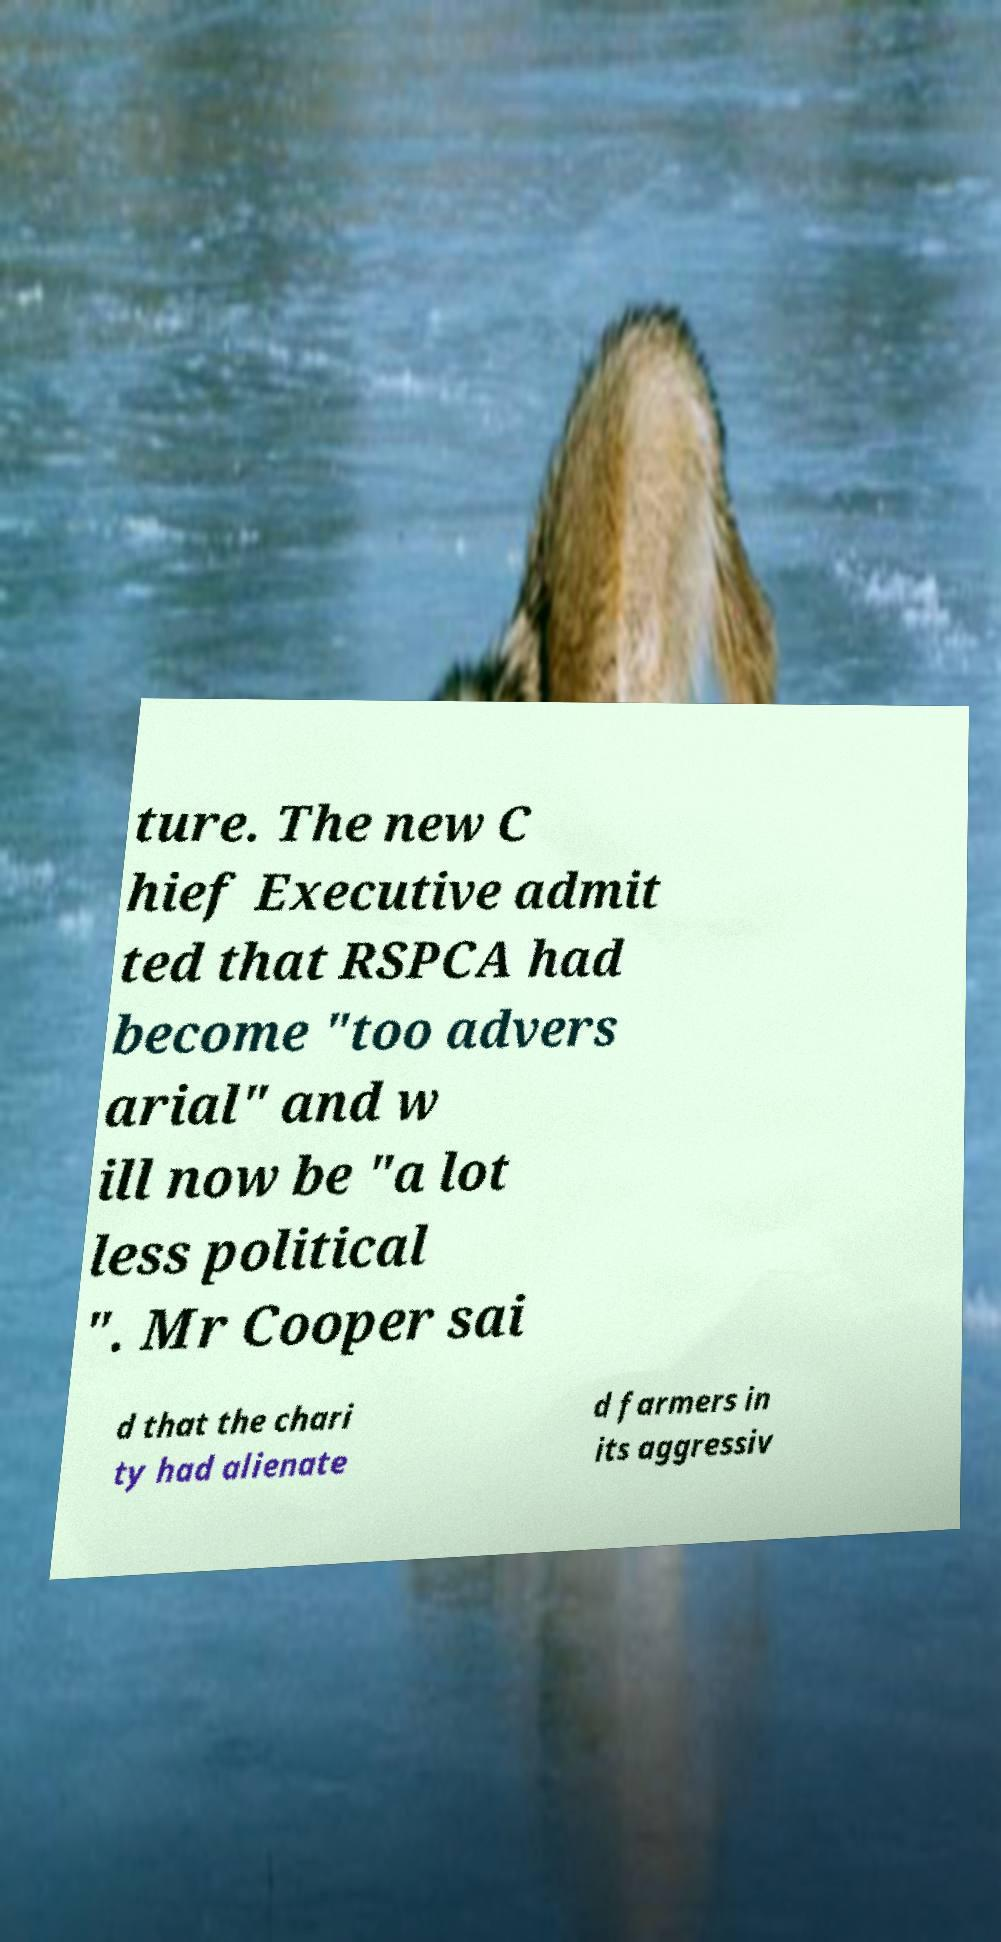Please identify and transcribe the text found in this image. ture. The new C hief Executive admit ted that RSPCA had become "too advers arial" and w ill now be "a lot less political ". Mr Cooper sai d that the chari ty had alienate d farmers in its aggressiv 